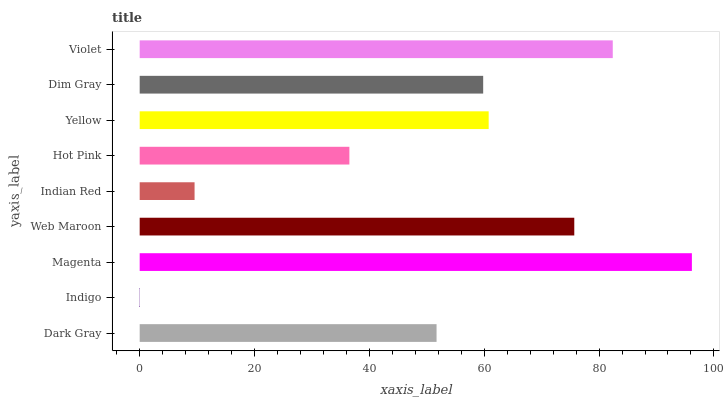Is Indigo the minimum?
Answer yes or no. Yes. Is Magenta the maximum?
Answer yes or no. Yes. Is Magenta the minimum?
Answer yes or no. No. Is Indigo the maximum?
Answer yes or no. No. Is Magenta greater than Indigo?
Answer yes or no. Yes. Is Indigo less than Magenta?
Answer yes or no. Yes. Is Indigo greater than Magenta?
Answer yes or no. No. Is Magenta less than Indigo?
Answer yes or no. No. Is Dim Gray the high median?
Answer yes or no. Yes. Is Dim Gray the low median?
Answer yes or no. Yes. Is Web Maroon the high median?
Answer yes or no. No. Is Indigo the low median?
Answer yes or no. No. 